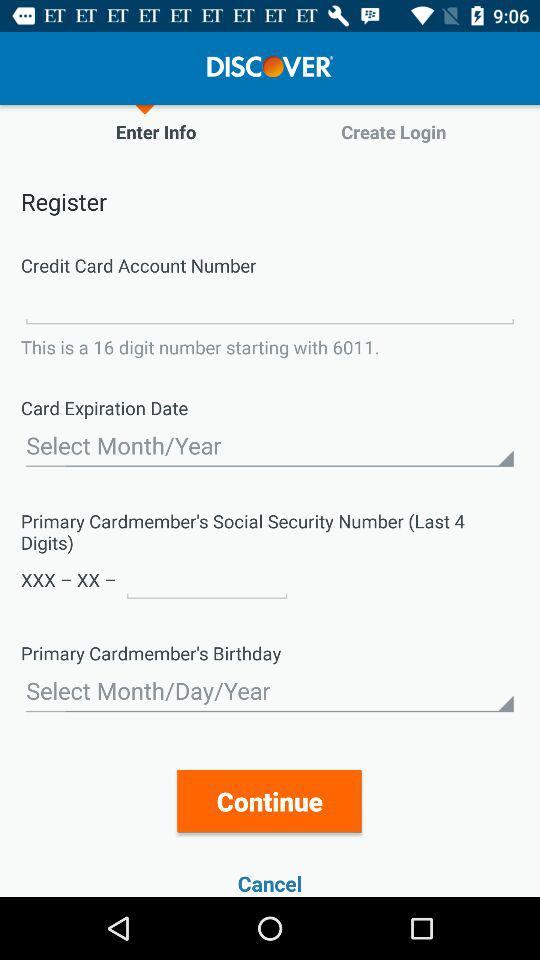What type of information is the user requested to enter in the first input field? The user is requested to enter the Credit Card Account Number, which is a 16-digit number starting with 6011, as indicated on the form.  Why might it be important to specify 'starting with 6011' for this type of entry? Specifying 'starting with 6011' helps to validate the type of credit card being entered. For instance, different credit card providers start with different numbers, and '6011' indicates a Discover card, ensuring that the entered information matches the type of account being registered. 